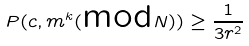Convert formula to latex. <formula><loc_0><loc_0><loc_500><loc_500>P ( c , m ^ { k } ( \text {mod} N ) ) \geq \frac { 1 } { 3 r ^ { 2 } }</formula> 